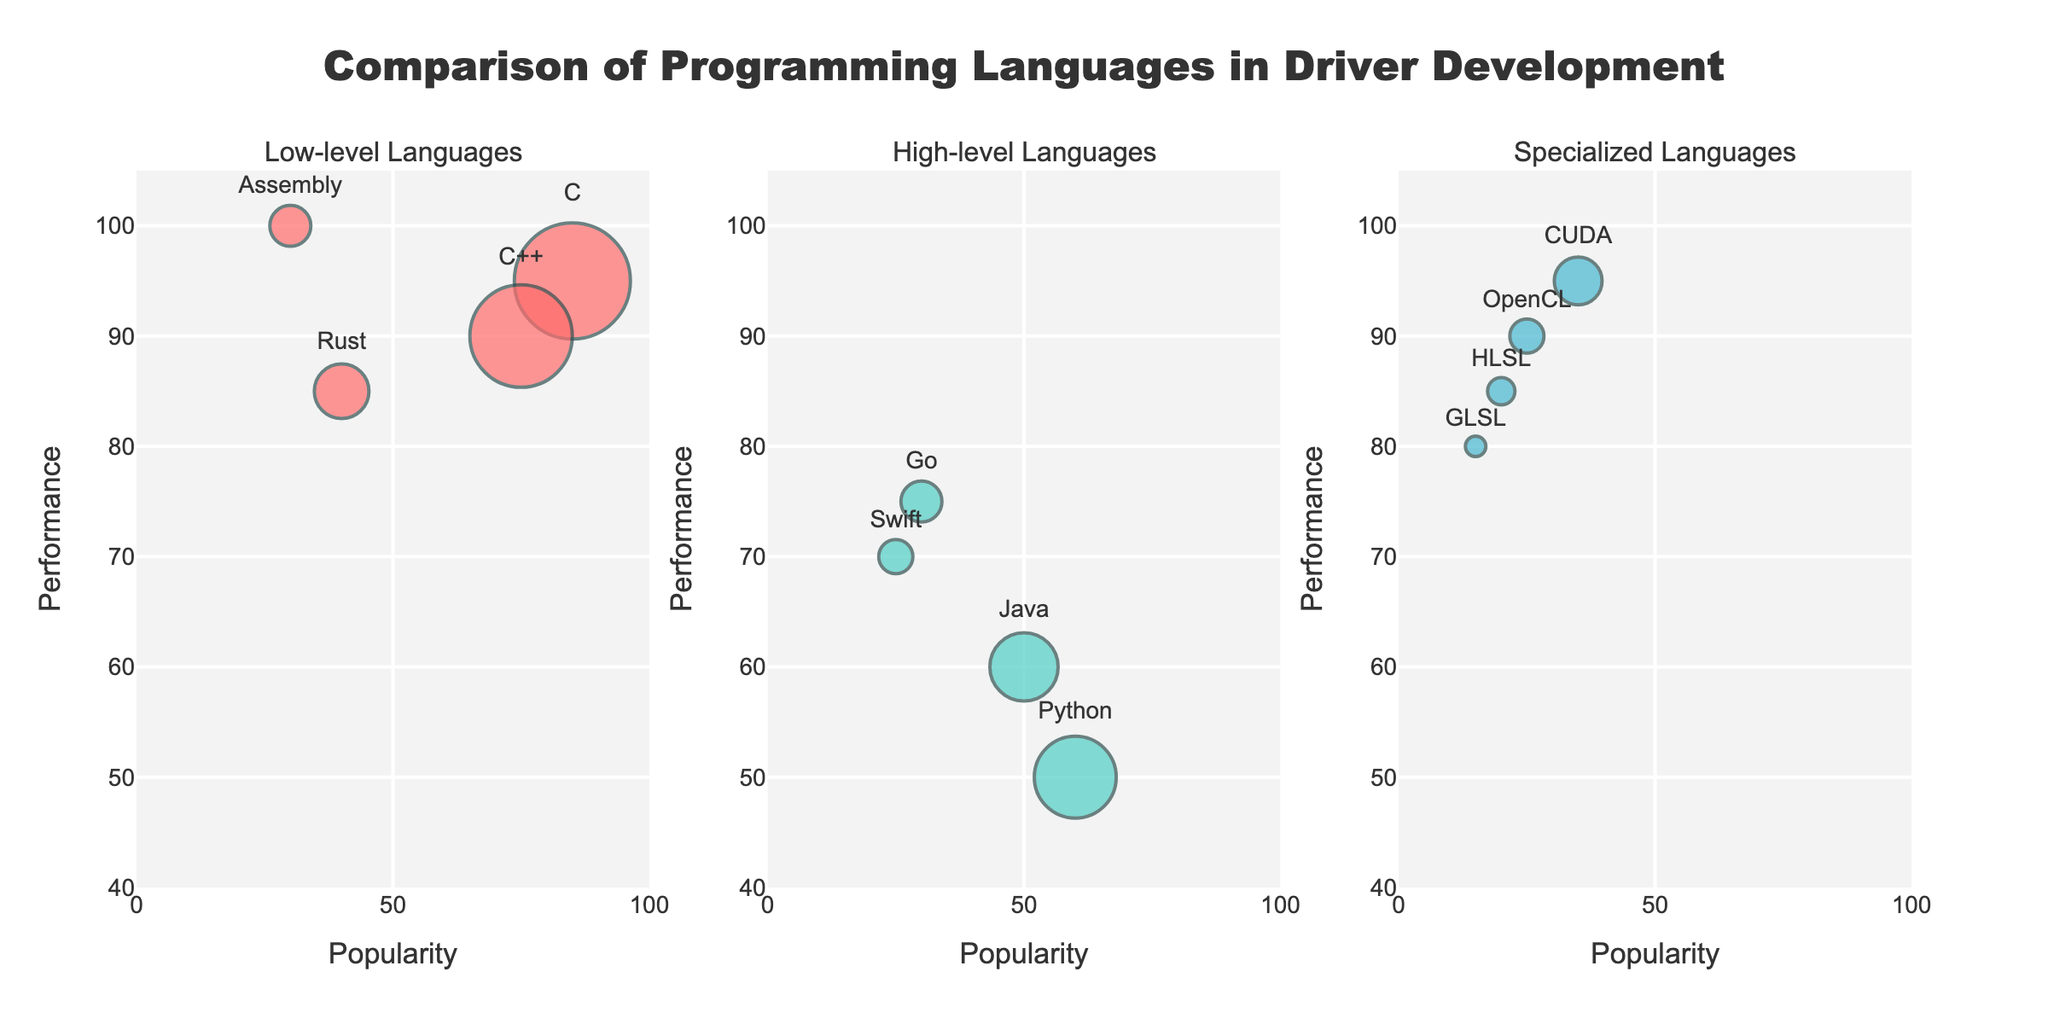What's the title of the figure? The title of the figure is typically displayed prominently at the top. In this case, it is "Comparison of Programming Languages in Driver Development".
Answer: Comparison of Programming Languages in Driver Development How is the popularity of programming languages represented? In the bubble chart, the size of each bubble represents the popularity. Larger bubbles indicate more popular languages.
Answer: By the size of bubbles Which low-level language has the highest performance? Look at the subplot for Low-level Languages and identify the language with the highest position on the Y-axis. Assembly is the highest on the Y-axis with a performance of 100.
Answer: Assembly How many programming languages are categorized as specialized? Count the number of bubbles in the Specialized Languages subplot. There are 4 languages: CUDA, OpenCL, HLSL, and GLSL.
Answer: 4 languages What are the popularity and performance of Python? Locate the bubble labeled "Python" in the High-level Languages subplot. Python has a popularity of 60 and a performance of 50.
Answer: Popularity: 60, Performance: 50 Which two languages have the closest performance values in the low-level category? Identify the languages in the Low-level Languages subplot and compare their performance values. Rust (85) and C++ (90) are the closest in performance.
Answer: Rust and C++ What is the average performance of specialized languages? Identify the performance values of the specialized languages: CUDA (95), OpenCL (90), HLSL (85), and GLSL (80). Compute the average: (95 + 90 + 85 + 80) / 4 = 87.5.
Answer: 87.5 Which high-level language has the smallest bubble size? Look at the High-level Languages subplot and find the smallest bubble. Swift has the smallest bubble, indicating the least popularity.
Answer: Swift Is any language equally popular among the high-level and specialized categories? Compare the popularity values of bubbles in both the High-level and Specialized subplots. No such language is found with equal popularity.
Answer: No 